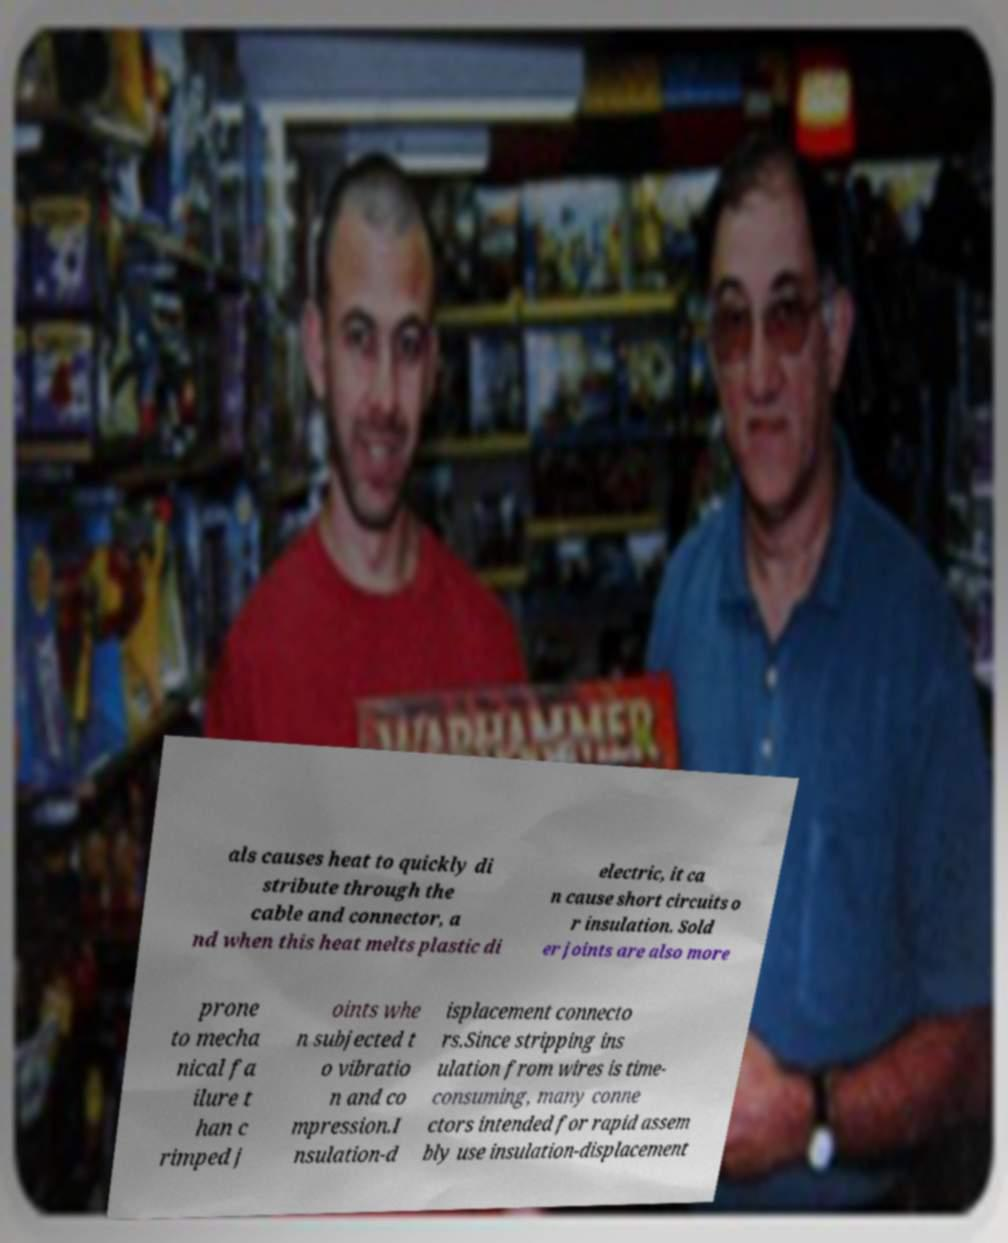Can you accurately transcribe the text from the provided image for me? als causes heat to quickly di stribute through the cable and connector, a nd when this heat melts plastic di electric, it ca n cause short circuits o r insulation. Sold er joints are also more prone to mecha nical fa ilure t han c rimped j oints whe n subjected t o vibratio n and co mpression.I nsulation-d isplacement connecto rs.Since stripping ins ulation from wires is time- consuming, many conne ctors intended for rapid assem bly use insulation-displacement 